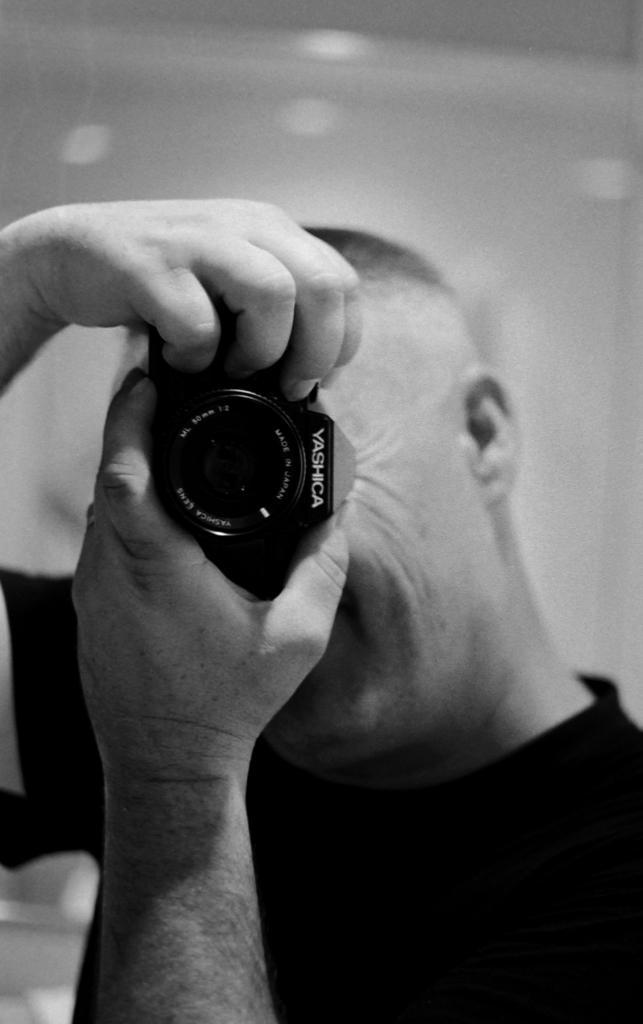How would you summarize this image in a sentence or two? In the middle of the image a man is standing and holding a camera in his hands. Behind him there is a wall. 